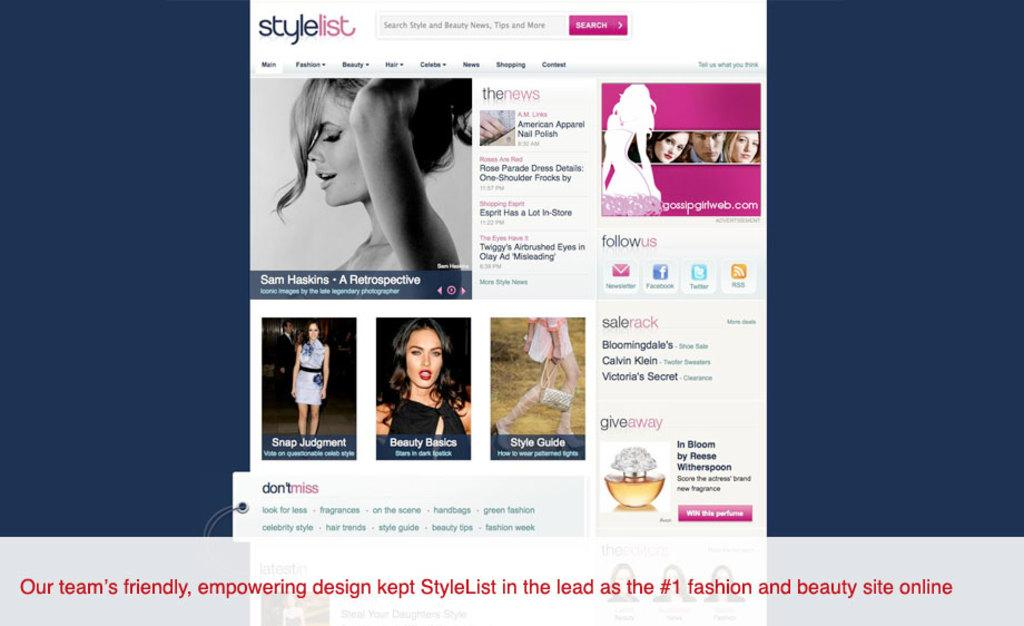What is the main subject of the image? The main subject of the image is a screenshot. What can be seen within the screenshot? The screenshot contains images of women. Are there any words or phrases visible in the screenshot? Yes, there is text present in the screenshot. What type of brake can be seen in the image? There is no brake present in the image; it contains a screenshot with images of women and text. How many thumbs are visible in the image? There is no thumb visible in the image; it contains a screenshot with images of women and text. 